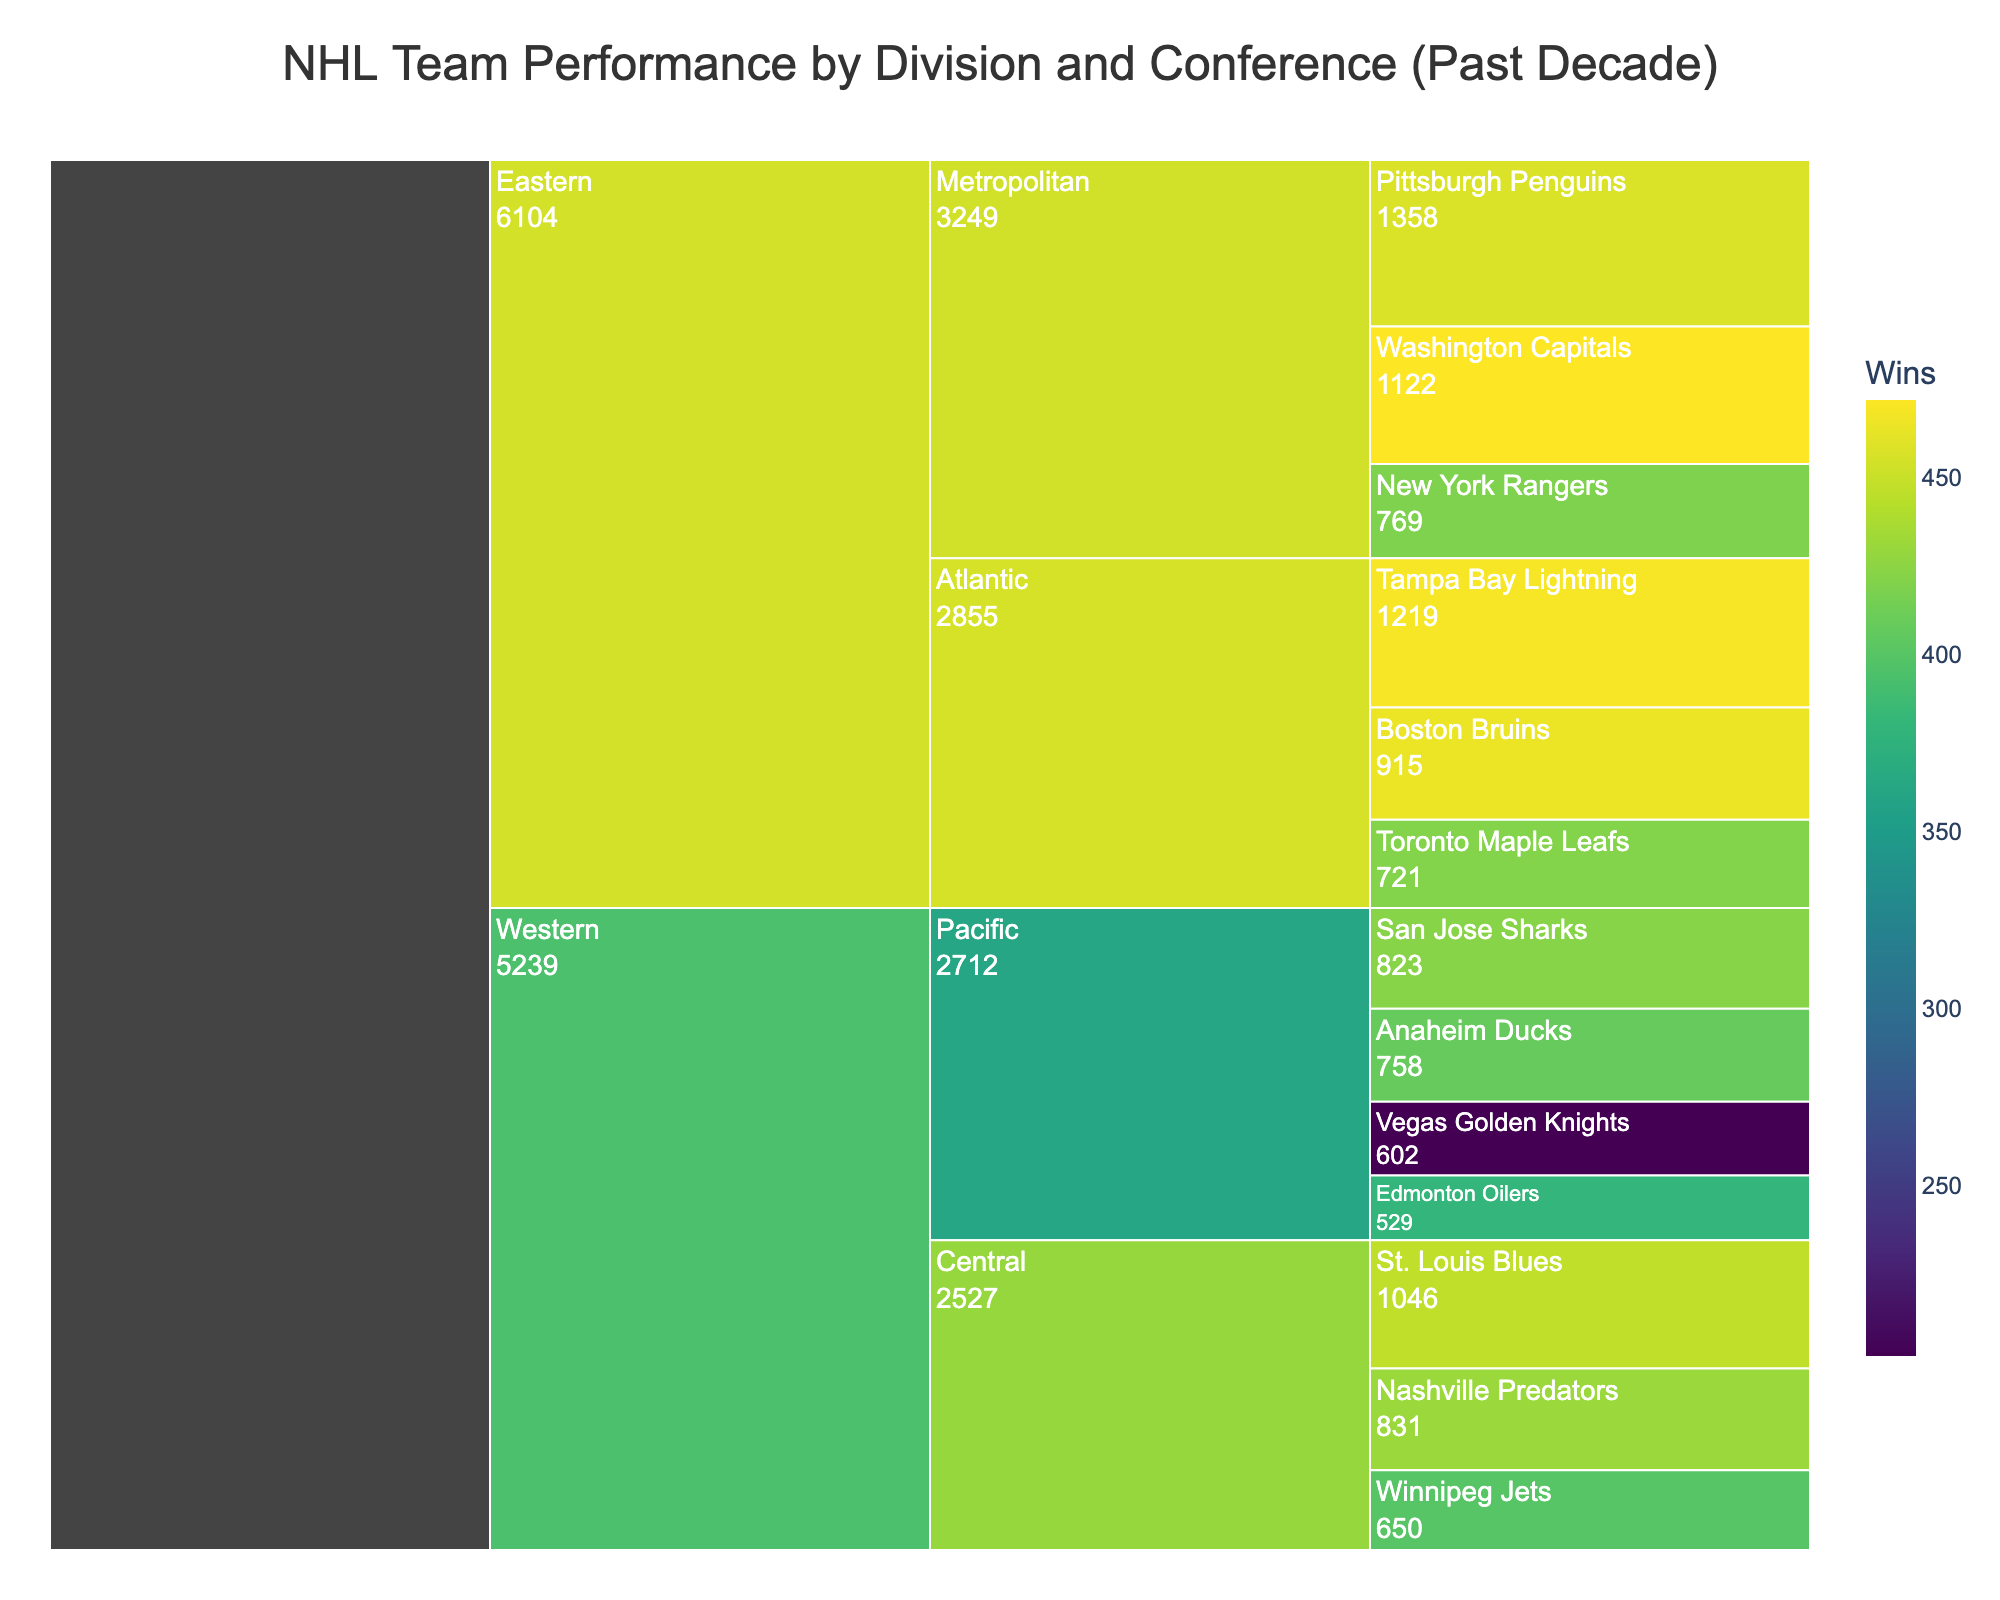What's the title of the chart? The title of the chart is displayed at the top center of the chart, usually in a larger and bold font. In this case, the title is "NHL Team Performance by Division and Conference (Past Decade)".
Answer: NHL Team Performance by Division and Conference (Past Decade) Which Eastern Conference team has won the most Stanley Cups in the past decade? To find this, look for the sections representing teams within the Eastern Conference. The team with the most Stanley Cups is highlighted in the hover data. Tampa Bay Lightning and Pittsburgh Penguins both have won 2 Stanley Cups.
Answer: Tampa Bay Lightning and Pittsburgh Penguins How many total wins do the Nashville Predators have? Hover over the section representing the Nashville Predators. The hover data will show the number of wins, which is 431.
Answer: 431 Which conference has more total wins, Eastern or Western? Calculate the total wins by summing up the wins for all teams in each conference. For the Western Conference: (423+408+202+379+446+431+400)=2689. For the Eastern Conference: (469+465+421+472+458+419)=2704. Therefore, the Eastern Conference has more total wins.
Answer: Eastern Conference Which team in the Central Division has the highest number of playoff appearances? Look for the sections within the Central Division and compare the playoff appearances listed in the hover data. The St. Louis Blues and Nashville Predators both have the highest with 8 playoff appearances.
Answer: St. Louis Blues and Nashville Predators What's the combined number of Stanley Cups won by teams in the Metropolitan Division? Sum up the number of Stanley Cups for teams in the Metropolitan Division: Washington Capitals (1) + Pittsburgh Penguins (2) = 3.
Answer: 3 Compare the wins of the San Jose Sharks with the Anaheim Ducks. Which team has won more games? Hover over both the San Jose Sharks and Anaheim Ducks sections to see their win totals. The San Jose Sharks have 423 wins, while the Anaheim Ducks have 408 wins. Therefore, the San Jose Sharks have more wins.
Answer: San Jose Sharks What is the average number of wins for teams in the Atlantic Division? Calculate the average by summing the wins and dividing by the number of teams. Wins for Atlantic Division: (469+465+421)=1355. Number of teams=3. So, average wins = 1355 / 3 = 451.67.
Answer: 451.67 How many teams have over 400 wins in the past decade? Count the sections where the number of wins exceeds 400. The teams are San Jose Sharks (423), Anaheim Ducks (408), St. Louis Blues (446), Nashville Predators (431), Winnipeg Jets (400), Tampa Bay Lightning (469), Boston Bruins (465), Toronto Maple Leafs (421), Washington Capitals (472), and Pittsburgh Penguins (458). There are 10 teams.
Answer: 10 What's the playoff appearance difference between the Western Conference and Eastern Conference? Sum the playoff appearances for each conference and find the difference. Western Conference: (8+7+4+3+8+8+5)=43. Eastern Conference: (7+9+6+9+10+7)=48. Difference = 48 - 43 = 5.
Answer: 5 